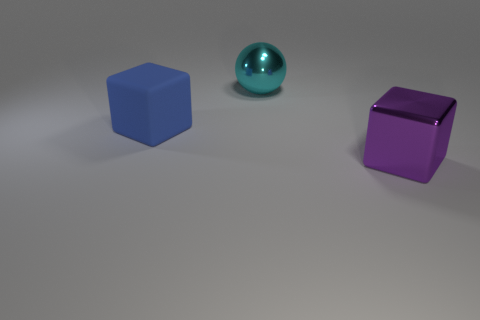What number of things are objects that are behind the big purple metallic object or big objects to the left of the big ball?
Make the answer very short. 2. Is the number of big blue cubes less than the number of tiny red blocks?
Make the answer very short. No. What number of objects are large things or blue cubes?
Ensure brevity in your answer.  3. Is the shape of the large blue thing the same as the large purple object?
Offer a terse response. Yes. Is there any other thing that has the same material as the cyan sphere?
Your response must be concise. Yes. Is the number of big blue objects the same as the number of things?
Provide a succinct answer. No. Does the metal thing that is on the right side of the cyan thing have the same size as the cube that is to the left of the cyan metallic ball?
Provide a succinct answer. Yes. The thing that is in front of the cyan ball and right of the rubber thing is made of what material?
Provide a succinct answer. Metal. Are there any other things of the same color as the large sphere?
Offer a terse response. No. Are there fewer shiny spheres that are in front of the cyan sphere than large blue objects?
Provide a short and direct response. Yes. 